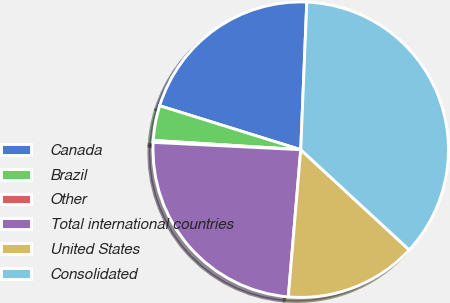<chart> <loc_0><loc_0><loc_500><loc_500><pie_chart><fcel>Canada<fcel>Brazil<fcel>Other<fcel>Total international countries<fcel>United States<fcel>Consolidated<nl><fcel>20.85%<fcel>3.81%<fcel>0.21%<fcel>24.45%<fcel>14.47%<fcel>36.22%<nl></chart> 